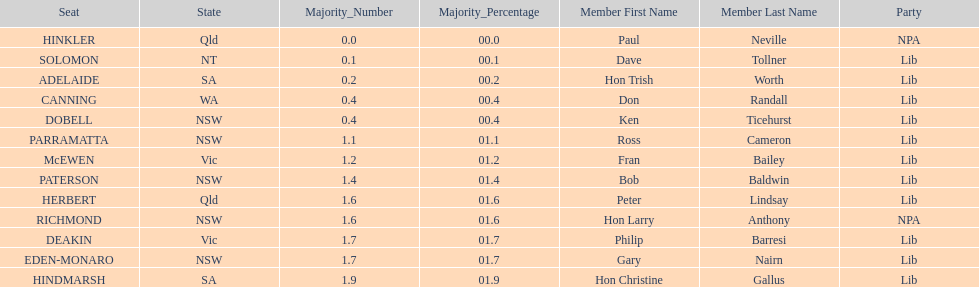What is the difference in majority between hindmarsh and hinkler? 01.9. 